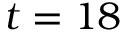<formula> <loc_0><loc_0><loc_500><loc_500>t = 1 8</formula> 